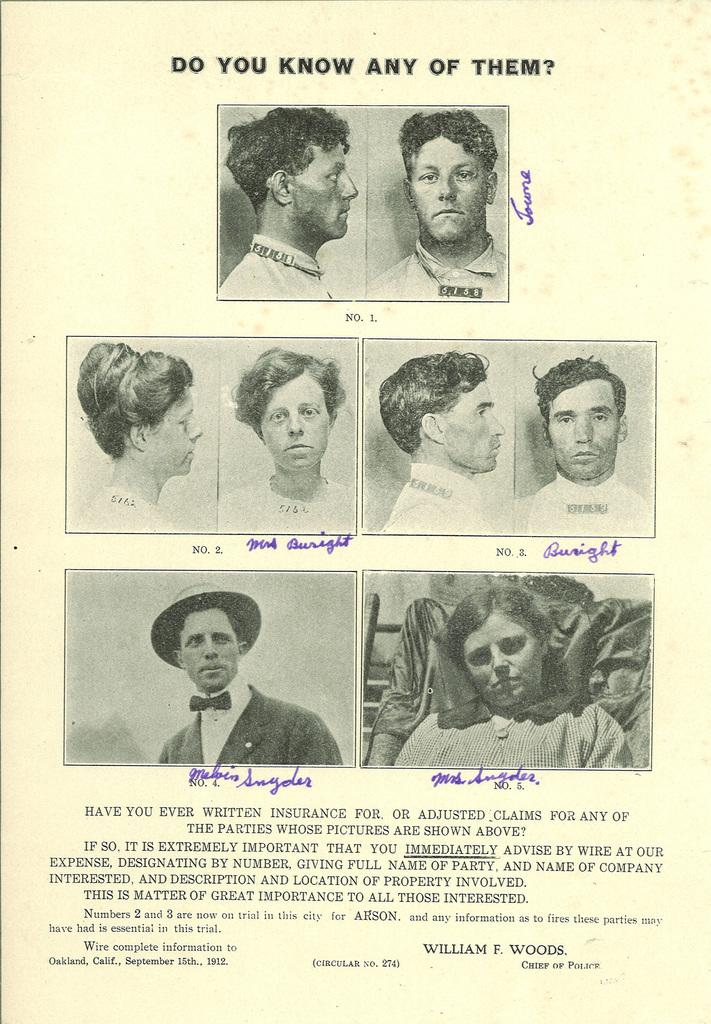What is the main object in the image? There is a paper in the image. What is depicted on the paper? The paper contains a depiction of people. Are there any words or letters on the paper? Yes, there is text on the paper. Reasoning: Let's think step by step by step in order to produce the conversation. We start by identifying the main object in the image, which is the paper. Then, we describe what is depicted on the paper, which is a depiction of people. Finally, we mention the presence of text on the paper. Each question is designed to elicit a specific detail about the image that is known from the provided facts. Absurd Question/Answer: What type of property can be seen in the background of the image? There is no property visible in the image; it only contains a paper with a depiction of people and text. What type of hill can be seen in the background of the image? There is no hill visible in the image; it only contains a paper with a depiction of people and text. 